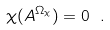<formula> <loc_0><loc_0><loc_500><loc_500>\chi ( A ^ { \Omega _ { \chi } } ) = 0 \ .</formula> 